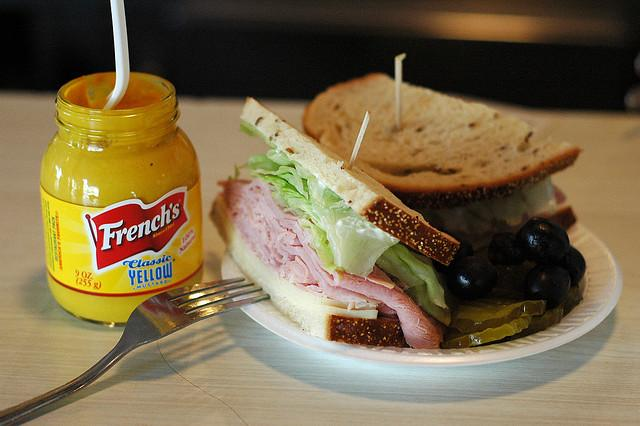Which one of these is a competitor of the company that make's the item in the jar?

Choices:
A) mitsubishi
B) gulden's
C) chiquita
D) apple gulden's 